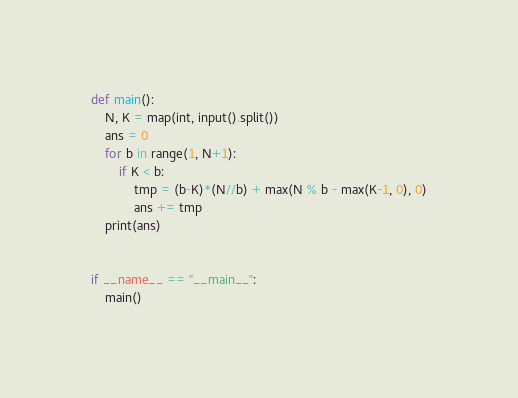Convert code to text. <code><loc_0><loc_0><loc_500><loc_500><_Python_>def main():
    N, K = map(int, input().split())
    ans = 0
    for b in range(1, N+1):
        if K < b:
            tmp = (b-K)*(N//b) + max(N % b - max(K-1, 0), 0)
            ans += tmp
    print(ans)


if __name__ == "__main__":
    main()
</code> 